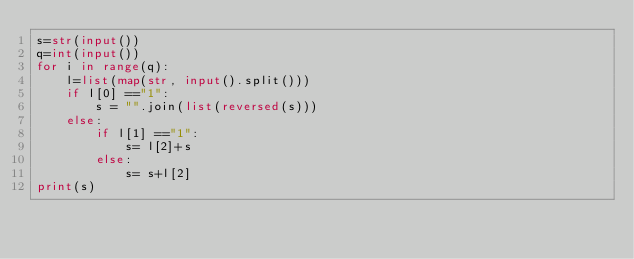<code> <loc_0><loc_0><loc_500><loc_500><_Python_>s=str(input())
q=int(input())
for i in range(q):
    l=list(map(str, input().split()))
    if l[0] =="1":
        s = "".join(list(reversed(s)))
    else:
        if l[1] =="1":
            s= l[2]+s
        else:
            s= s+l[2]
print(s)
</code> 